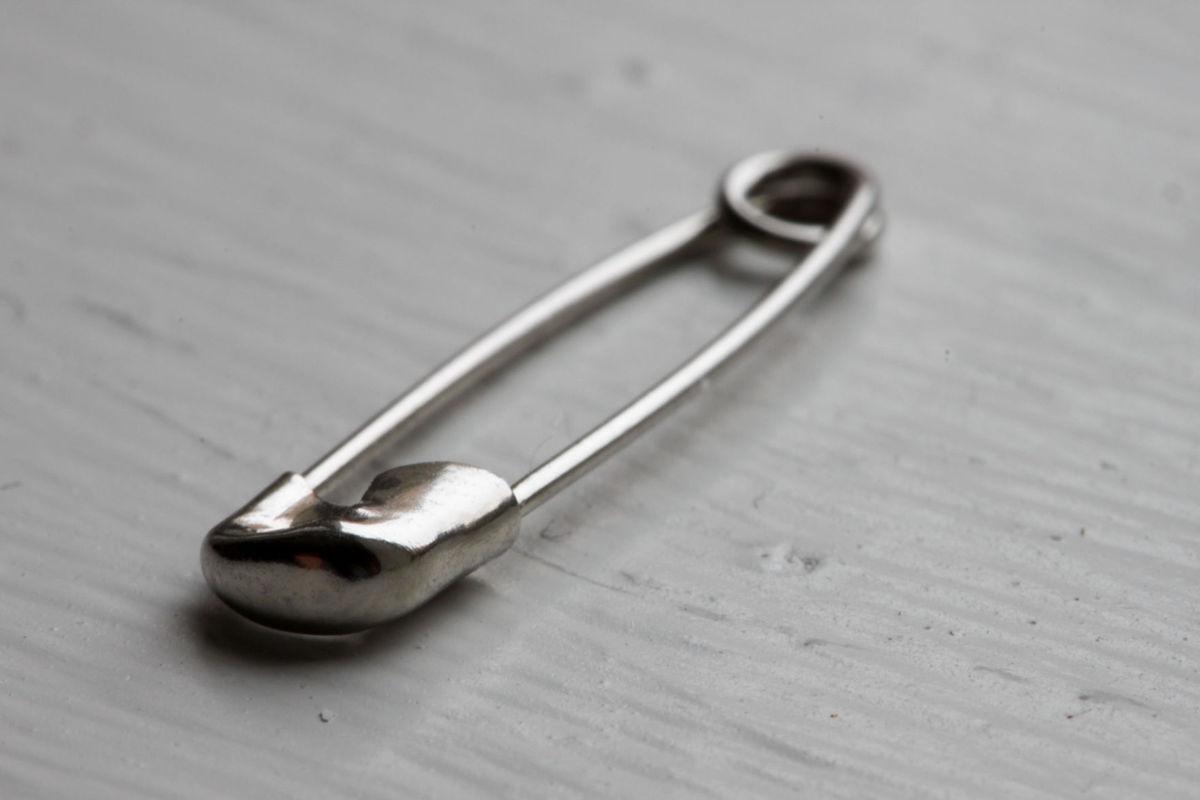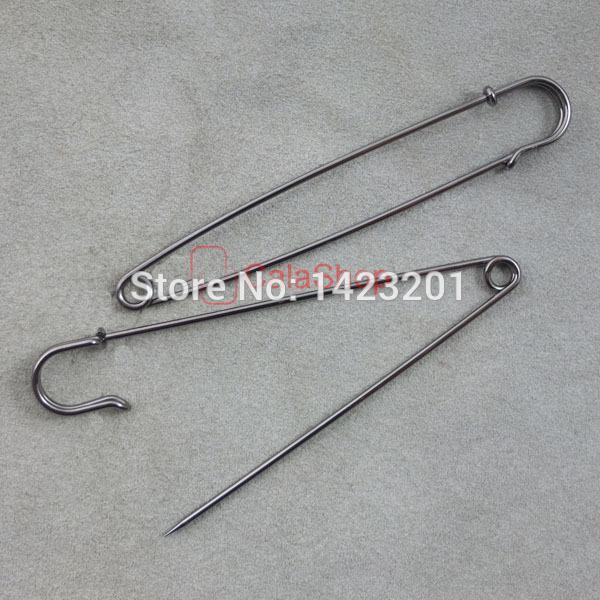The first image is the image on the left, the second image is the image on the right. Given the left and right images, does the statement "There is one safety pin that is open." hold true? Answer yes or no. Yes. 